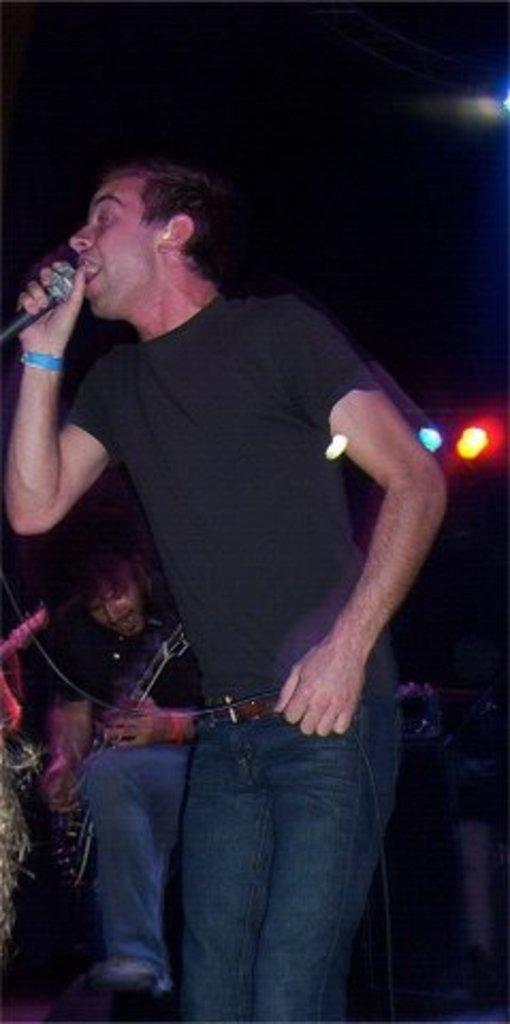What is the man in the image holding? The man is holding a microphone in the image. What is another person in the image doing? There is a person playing a guitar in the image. What can be seen in the background or surroundings of the image? Lights are visible in the image. What type of chalk is being used to draw on the sofa in the image? There is no chalk or sofa present in the image. How many grapes are visible on the person playing the guitar in the image? There are no grapes visible in the image. 